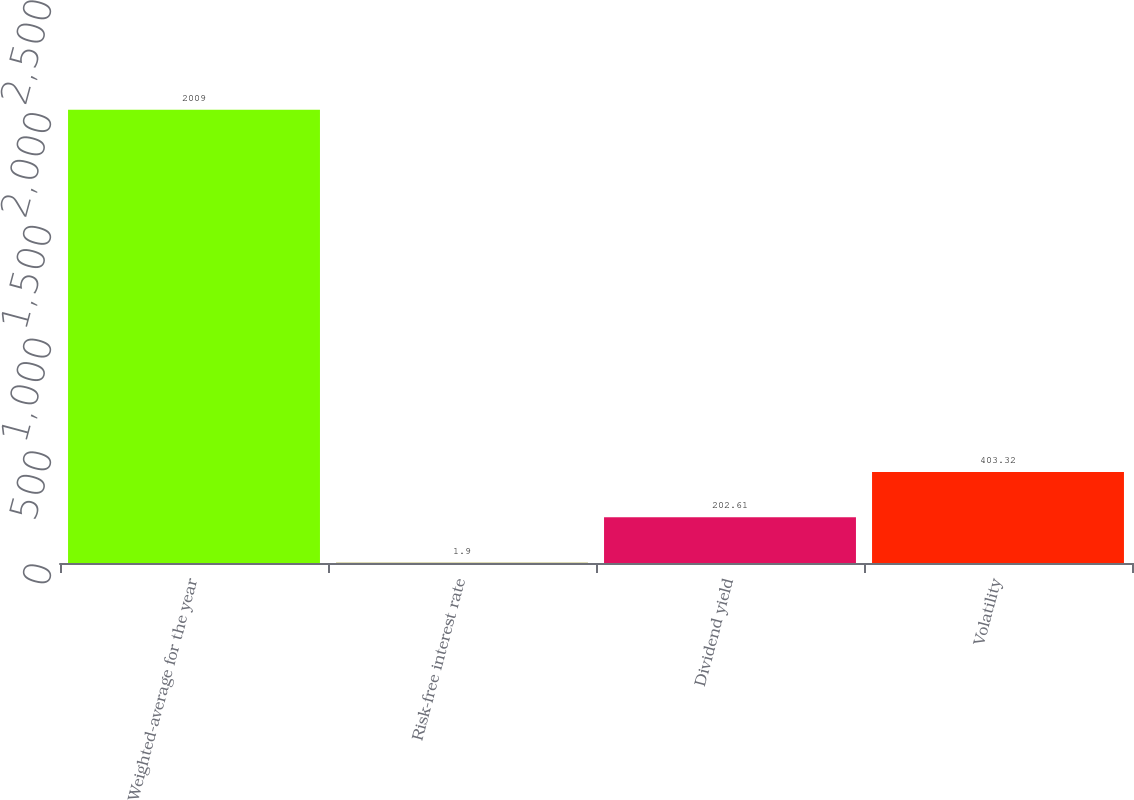Convert chart to OTSL. <chart><loc_0><loc_0><loc_500><loc_500><bar_chart><fcel>Weighted-average for the year<fcel>Risk-free interest rate<fcel>Dividend yield<fcel>Volatility<nl><fcel>2009<fcel>1.9<fcel>202.61<fcel>403.32<nl></chart> 